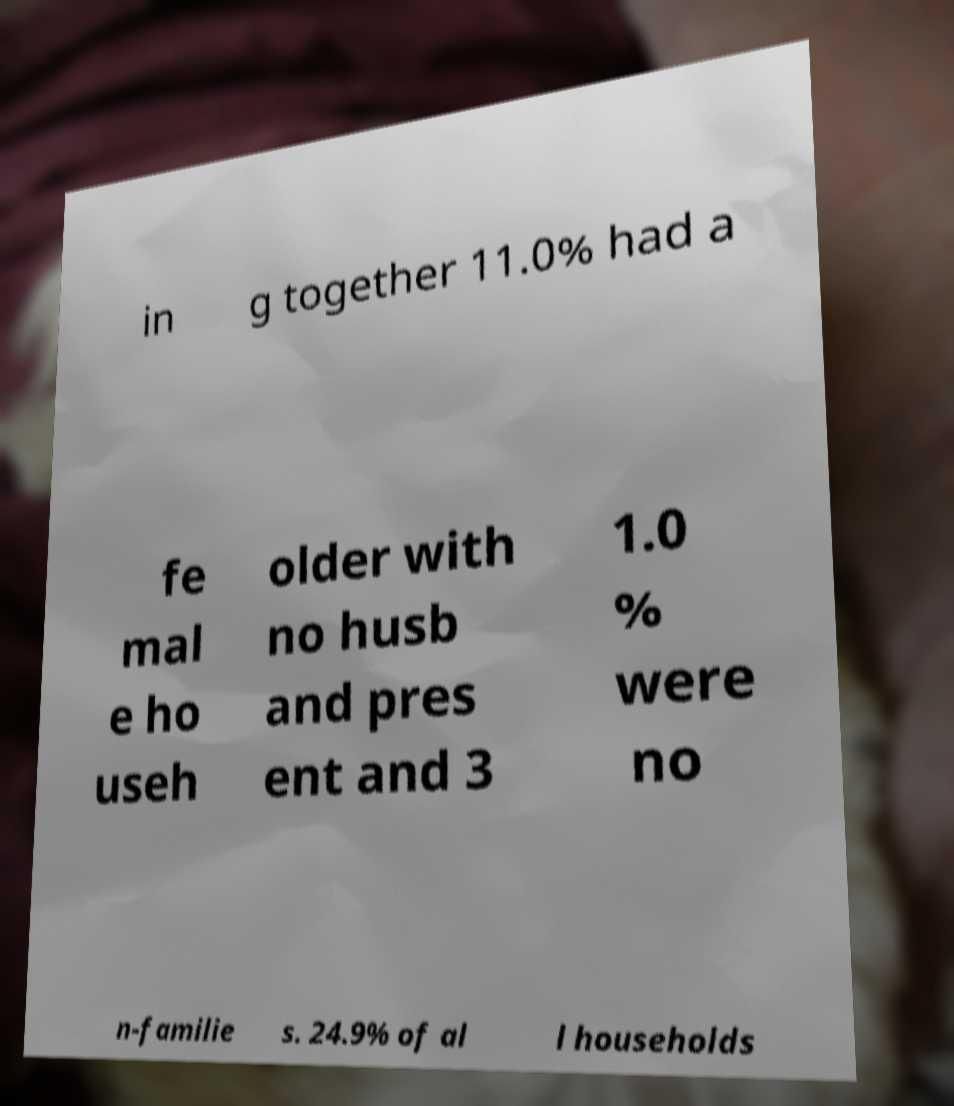Please read and relay the text visible in this image. What does it say? in g together 11.0% had a fe mal e ho useh older with no husb and pres ent and 3 1.0 % were no n-familie s. 24.9% of al l households 